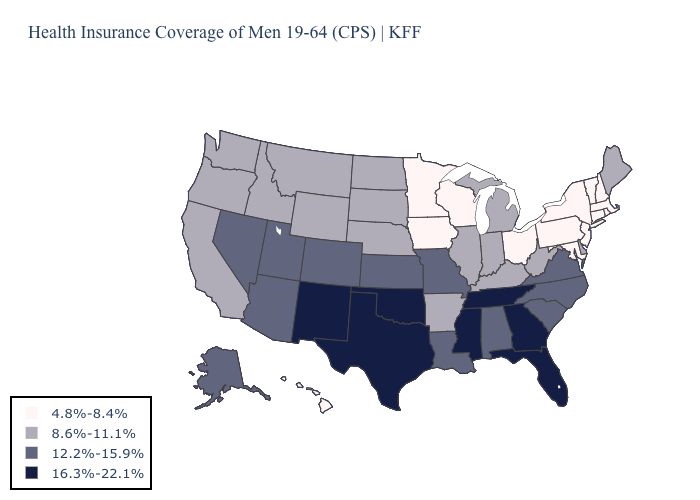What is the value of New York?
Be succinct. 4.8%-8.4%. Name the states that have a value in the range 4.8%-8.4%?
Give a very brief answer. Connecticut, Hawaii, Iowa, Maryland, Massachusetts, Minnesota, New Hampshire, New Jersey, New York, Ohio, Pennsylvania, Rhode Island, Vermont, Wisconsin. Does Kansas have the same value as North Carolina?
Be succinct. Yes. Which states have the lowest value in the USA?
Write a very short answer. Connecticut, Hawaii, Iowa, Maryland, Massachusetts, Minnesota, New Hampshire, New Jersey, New York, Ohio, Pennsylvania, Rhode Island, Vermont, Wisconsin. What is the value of Indiana?
Write a very short answer. 8.6%-11.1%. Among the states that border Maine , which have the highest value?
Be succinct. New Hampshire. Does Georgia have the lowest value in the USA?
Concise answer only. No. What is the value of South Dakota?
Concise answer only. 8.6%-11.1%. Which states have the lowest value in the USA?
Answer briefly. Connecticut, Hawaii, Iowa, Maryland, Massachusetts, Minnesota, New Hampshire, New Jersey, New York, Ohio, Pennsylvania, Rhode Island, Vermont, Wisconsin. Does Oregon have a lower value than Colorado?
Concise answer only. Yes. Name the states that have a value in the range 4.8%-8.4%?
Write a very short answer. Connecticut, Hawaii, Iowa, Maryland, Massachusetts, Minnesota, New Hampshire, New Jersey, New York, Ohio, Pennsylvania, Rhode Island, Vermont, Wisconsin. What is the value of Utah?
Give a very brief answer. 12.2%-15.9%. How many symbols are there in the legend?
Give a very brief answer. 4. 